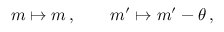<formula> <loc_0><loc_0><loc_500><loc_500>m \mapsto m \, , \quad m ^ { \prime } \mapsto m ^ { \prime } - \theta \, ,</formula> 